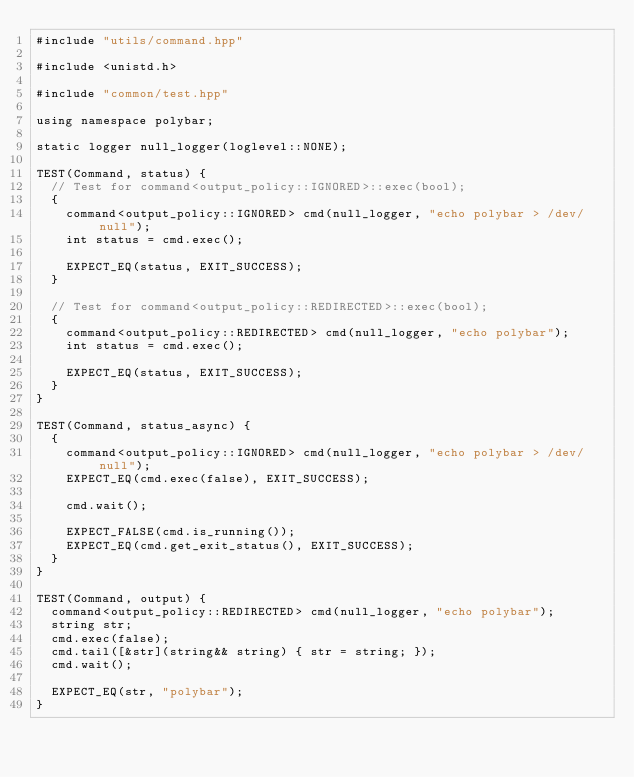Convert code to text. <code><loc_0><loc_0><loc_500><loc_500><_C++_>#include "utils/command.hpp"

#include <unistd.h>

#include "common/test.hpp"

using namespace polybar;

static logger null_logger(loglevel::NONE);

TEST(Command, status) {
  // Test for command<output_policy::IGNORED>::exec(bool);
  {
    command<output_policy::IGNORED> cmd(null_logger, "echo polybar > /dev/null");
    int status = cmd.exec();

    EXPECT_EQ(status, EXIT_SUCCESS);
  }

  // Test for command<output_policy::REDIRECTED>::exec(bool);
  {
    command<output_policy::REDIRECTED> cmd(null_logger, "echo polybar");
    int status = cmd.exec();

    EXPECT_EQ(status, EXIT_SUCCESS);
  }
}

TEST(Command, status_async) {
  {
    command<output_policy::IGNORED> cmd(null_logger, "echo polybar > /dev/null");
    EXPECT_EQ(cmd.exec(false), EXIT_SUCCESS);

    cmd.wait();

    EXPECT_FALSE(cmd.is_running());
    EXPECT_EQ(cmd.get_exit_status(), EXIT_SUCCESS);
  }
}

TEST(Command, output) {
  command<output_policy::REDIRECTED> cmd(null_logger, "echo polybar");
  string str;
  cmd.exec(false);
  cmd.tail([&str](string&& string) { str = string; });
  cmd.wait();

  EXPECT_EQ(str, "polybar");
}
</code> 